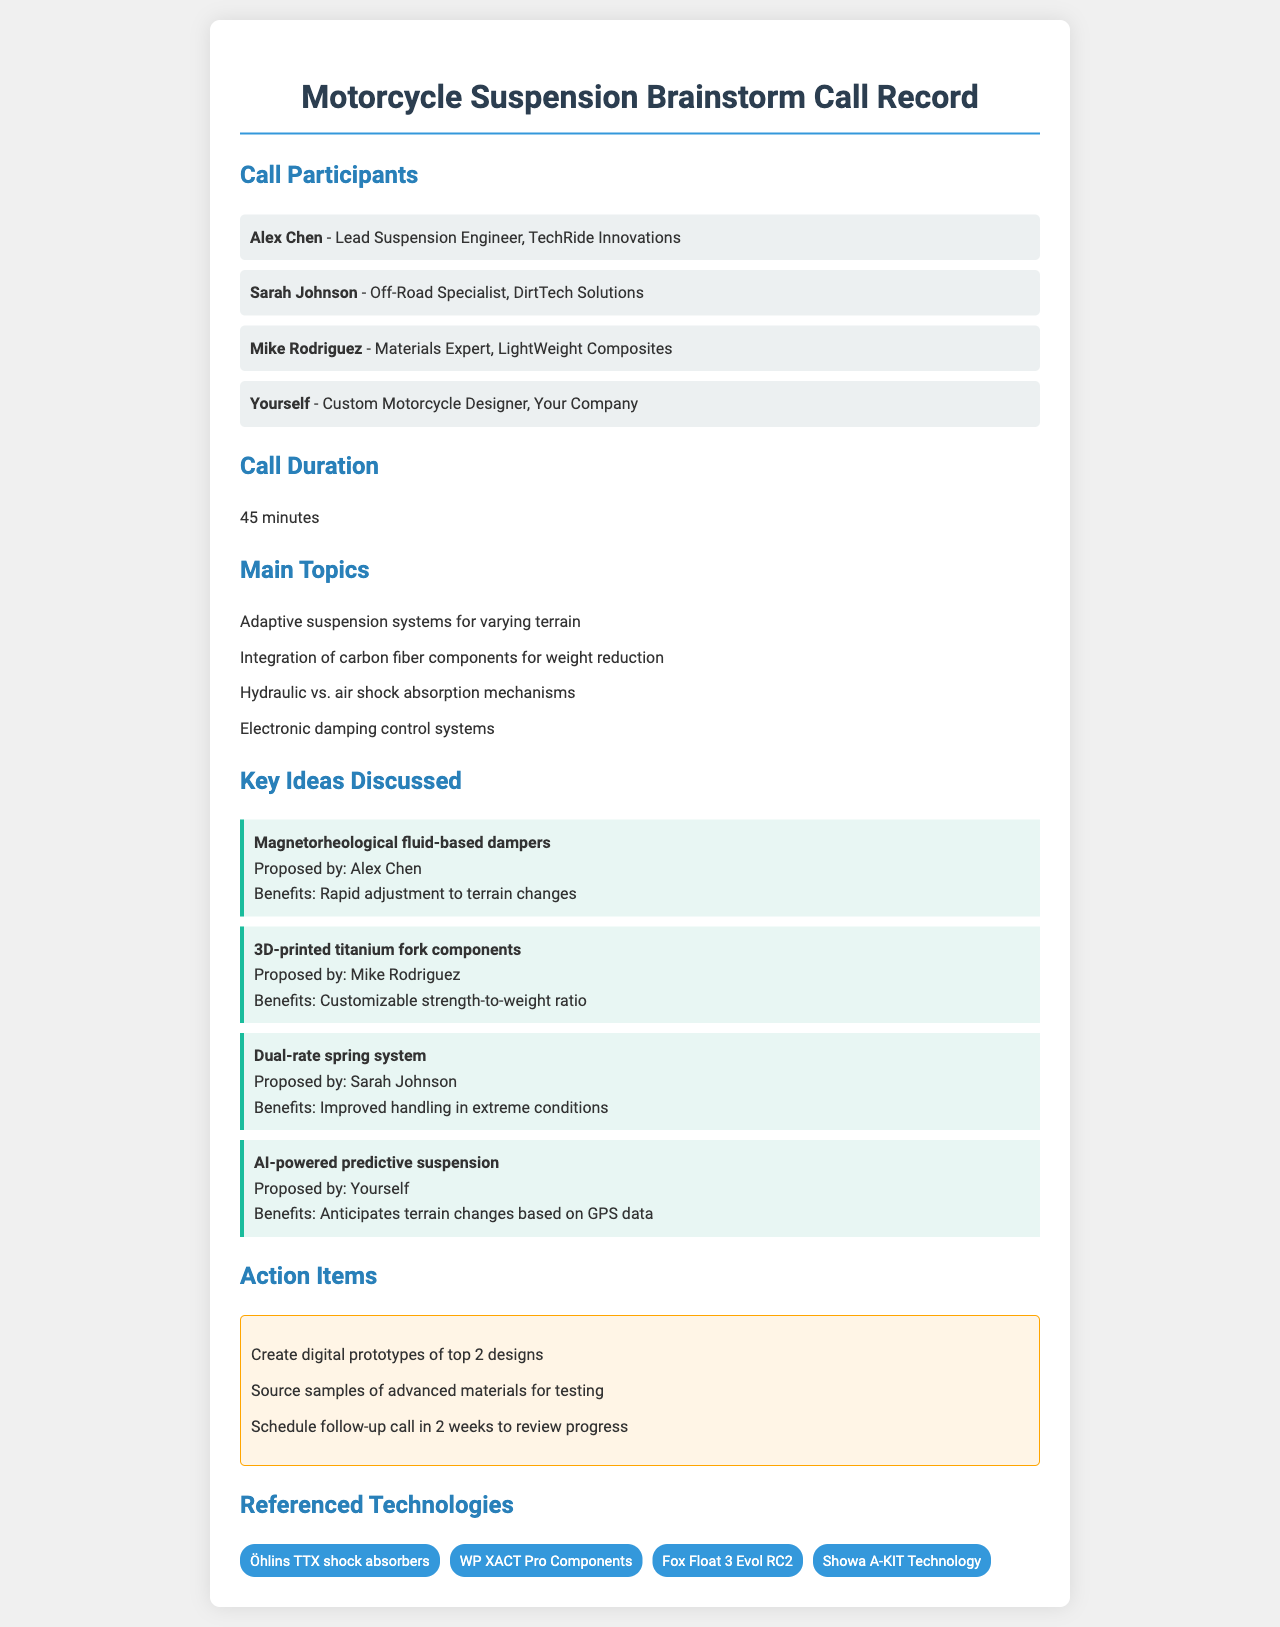What is the duration of the call? The duration of the call is specified as 45 minutes.
Answer: 45 minutes Who proposed the idea of AI-powered predictive suspension? The document states that the idea was proposed by "Yourself," referring to the user.
Answer: Yourself Which component was suggested to be made from 3D printing? The document mentions that the "3D-printed titanium fork components" were proposed during the call.
Answer: 3D-printed titanium fork components What technologies were referenced in the document? The document lists technologies such as Öhlins TTX shock absorbers and Fox Float 3 Evol RC2 among others.
Answer: Öhlins TTX shock absorbers, WP XACT Pro Components, Fox Float 3 Evol RC2, Showa A-KIT Technology What is one benefit of the dual-rate spring system? The document notes that the benefit includes "Improved handling in extreme conditions."
Answer: Improved handling in extreme conditions How many participants were on the call? The document lists four participants, including "Yourself".
Answer: Four participants What is one action item mentioned in the document? The document specifies that one action item is to "Create digital prototypes of top 2 designs."
Answer: Create digital prototypes of top 2 designs Which engineer is responsible for materials expertise? The document states that Mike Rodriguez is the materials expert.
Answer: Mike Rodriguez 